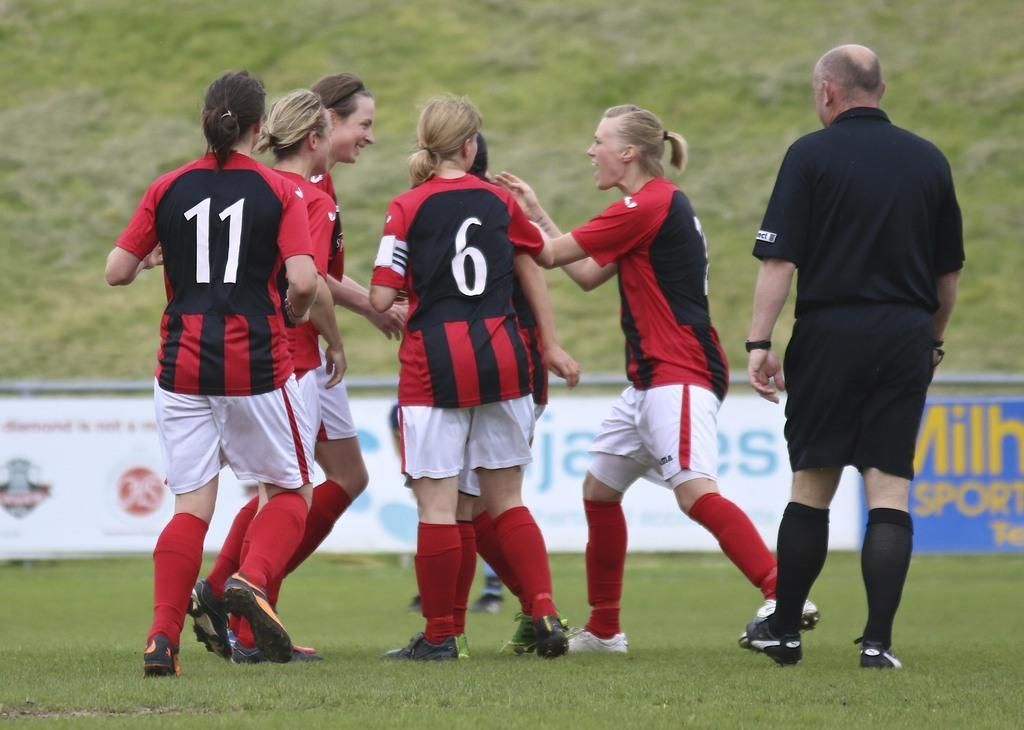<image>
Provide a brief description of the given image. Number 6 from a soccer team has her back facing the camera. 